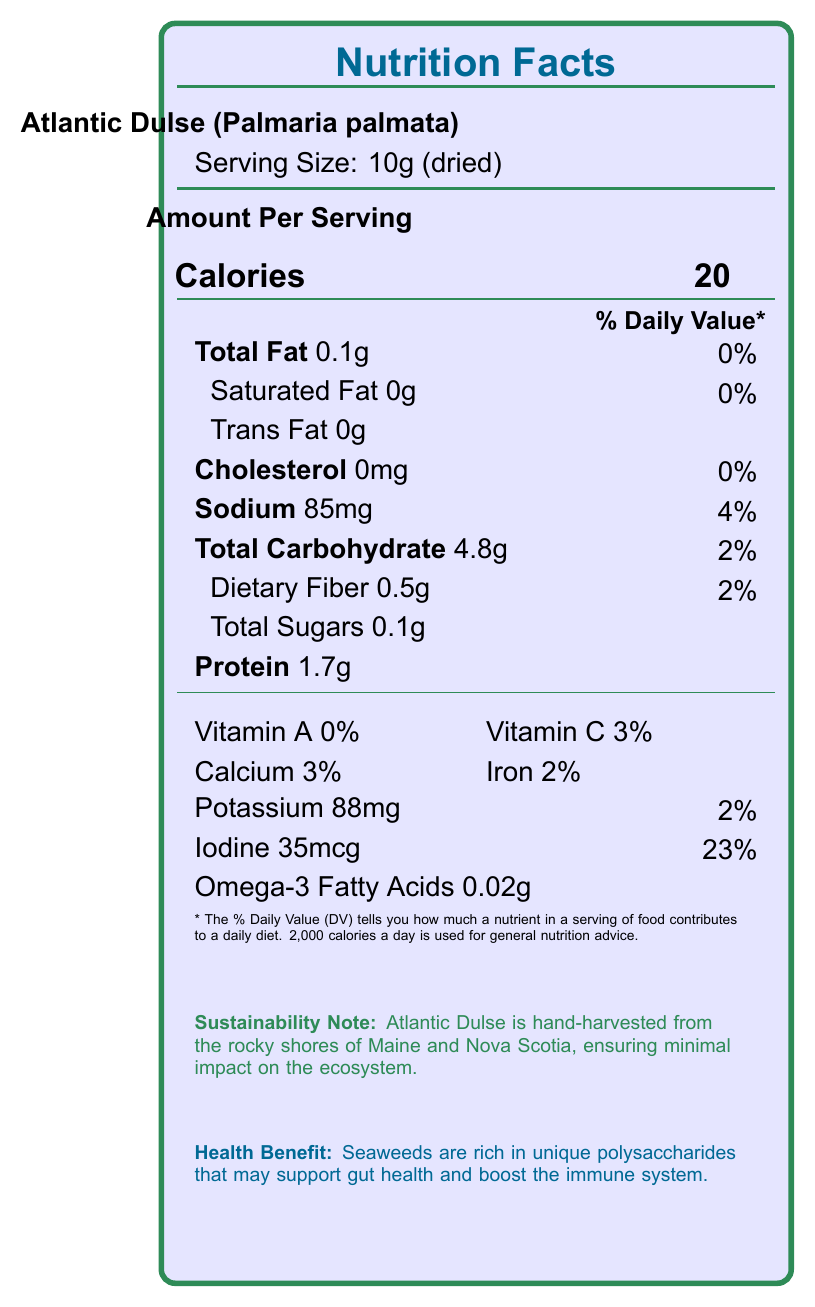what is the serving size for Atlantic Dulse? The document specifies that the serving size for Atlantic Dulse is 10 grams when dried.
Answer: 10g (dried) how many calories are in a serving of Atlantic Dulse? The document indicates that a serving of Atlantic Dulse contains 20 calories.
Answer: 20 What percentage of the Daily Value (DV) for sodium does Atlantic Dulse provide? The document shows that Atlantic Dulse contains 85mg of sodium, which is 4% of the Daily Value.
Answer: 4% Does Atlantic Dulse contain any trans fats? The document states that Atlantic Dulse has 0 grams of trans fat.
Answer: No What is the iodine content in Atlantic Dulse? The document lists the iodine content as 35 micrograms.
Answer: 35mcg Which of the following nutrients is NOT present in Atlantic Dulse?
A. Vitamin A
B. Omega-3 Fatty Acids
C. Cholesterol
D. Total Sugars
E. Protein The document shows that Atlantic Dulse has 0% of Vitamin A, indicating it is not present.
Answer: A What is the main sustainability note for Atlantic Dulse? The document includes a note that highlights the hand-harvesting method used for Atlantic Dulse which minimizes ecosystem impact.
Answer: Atlantic Dulse is hand-harvested from the rocky shores of Maine and Nova Scotia, ensuring minimal impact on the ecosystem. Which health benefit is associated with seaweeds according to the document?
1. Supports gut health
2. Reduces blood pressure
3. Lowers cholesterol
4. Improves vision The document states that seaweeds are rich in polysaccharides that may support gut health and boost the immune system.
Answer: 1 Does Atlantic Dulse have any cholesterol? The document states that Atlantic Dulse has 0mg of cholesterol.
Answer: No Summarize the main nutritional attributes of Atlantic Dulse. The document outlines Atlantic Dulse's nutrient content (including calories, fat, protein, vitamins, and minerals), its sustainability, and its health benefits.
Answer: Atlantic Dulse is a low-calorie, low-fat seaweed high in iodine and potassium with moderate amounts of protein and carbohydrates. It's sustainably harvested, offers health benefits such as supporting gut health, and is free from trans fats and cholesterol. What is the specific amount of omega-3 fatty acids in Atlantic Dulse? The document lists omega-3 fatty acids as 0.02 grams per serving in Atlantic Dulse.
Answer: 0.02g What is the calcium content per serving in Atlantic Dulse according to the document? The document indicates that Atlantic Dulse contains 3% of the Daily Value for calcium.
Answer: 3% Is the Vitamin A content more significant in Atlantic Dulse or Wakame? The document only provides the nutritional details for Atlantic Dulse. Information about Wakame is not included.
Answer: Cannot be determined What is the protein content in a serving of Atlantic Dulse? The document specifies that Atlantic Dulse contains 1.7 grams of protein per serving.
Answer: 1.7g 